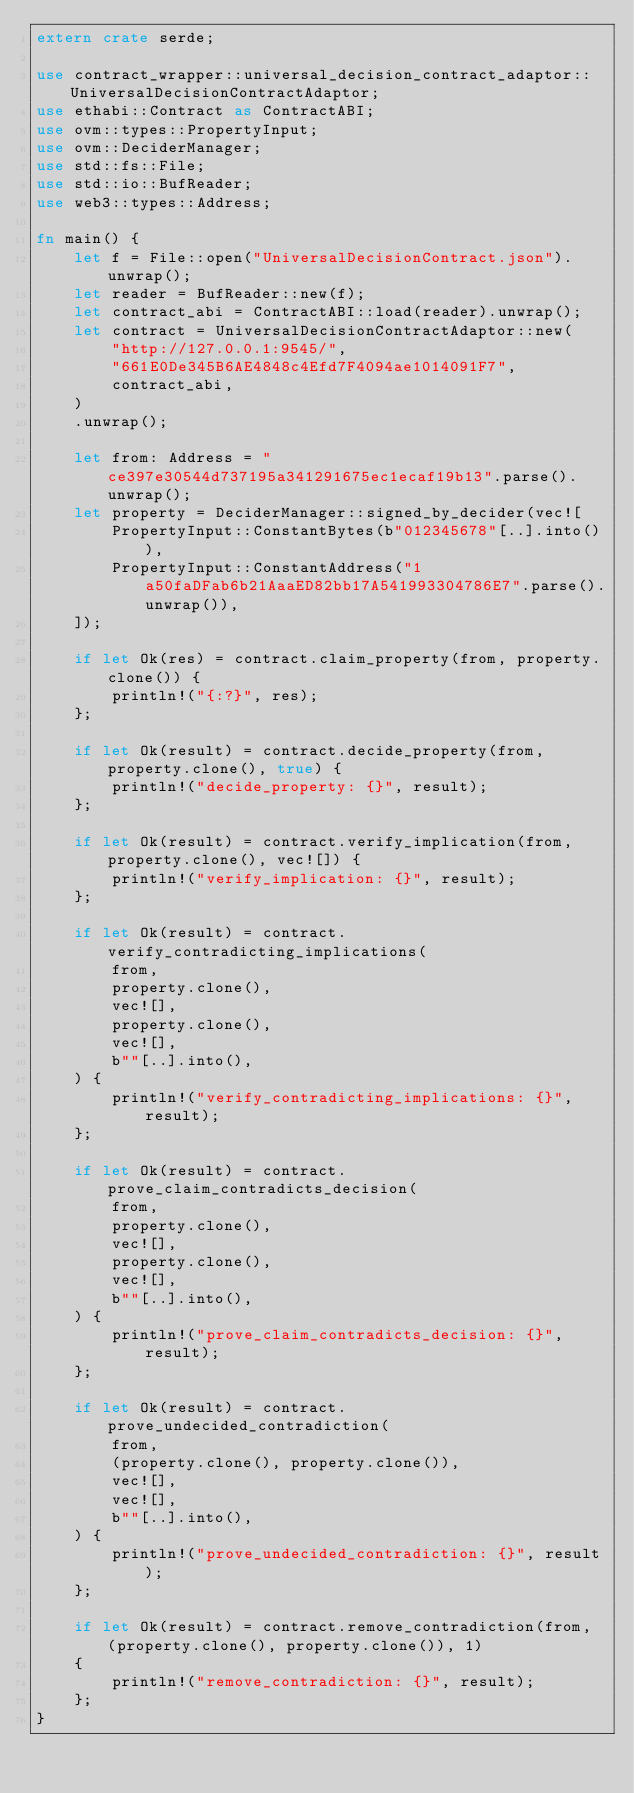<code> <loc_0><loc_0><loc_500><loc_500><_Rust_>extern crate serde;

use contract_wrapper::universal_decision_contract_adaptor::UniversalDecisionContractAdaptor;
use ethabi::Contract as ContractABI;
use ovm::types::PropertyInput;
use ovm::DeciderManager;
use std::fs::File;
use std::io::BufReader;
use web3::types::Address;

fn main() {
    let f = File::open("UniversalDecisionContract.json").unwrap();
    let reader = BufReader::new(f);
    let contract_abi = ContractABI::load(reader).unwrap();
    let contract = UniversalDecisionContractAdaptor::new(
        "http://127.0.0.1:9545/",
        "661E0De345B6AE4848c4Efd7F4094ae1014091F7",
        contract_abi,
    )
    .unwrap();

    let from: Address = "ce397e30544d737195a341291675ec1ecaf19b13".parse().unwrap();
    let property = DeciderManager::signed_by_decider(vec![
        PropertyInput::ConstantBytes(b"012345678"[..].into()),
        PropertyInput::ConstantAddress("1a50faDFab6b21AaaED82bb17A541993304786E7".parse().unwrap()),
    ]);

    if let Ok(res) = contract.claim_property(from, property.clone()) {
        println!("{:?}", res);
    };

    if let Ok(result) = contract.decide_property(from, property.clone(), true) {
        println!("decide_property: {}", result);
    };

    if let Ok(result) = contract.verify_implication(from, property.clone(), vec![]) {
        println!("verify_implication: {}", result);
    };

    if let Ok(result) = contract.verify_contradicting_implications(
        from,
        property.clone(),
        vec![],
        property.clone(),
        vec![],
        b""[..].into(),
    ) {
        println!("verify_contradicting_implications: {}", result);
    };

    if let Ok(result) = contract.prove_claim_contradicts_decision(
        from,
        property.clone(),
        vec![],
        property.clone(),
        vec![],
        b""[..].into(),
    ) {
        println!("prove_claim_contradicts_decision: {}", result);
    };

    if let Ok(result) = contract.prove_undecided_contradiction(
        from,
        (property.clone(), property.clone()),
        vec![],
        vec![],
        b""[..].into(),
    ) {
        println!("prove_undecided_contradiction: {}", result);
    };

    if let Ok(result) = contract.remove_contradiction(from, (property.clone(), property.clone()), 1)
    {
        println!("remove_contradiction: {}", result);
    };
}
</code> 